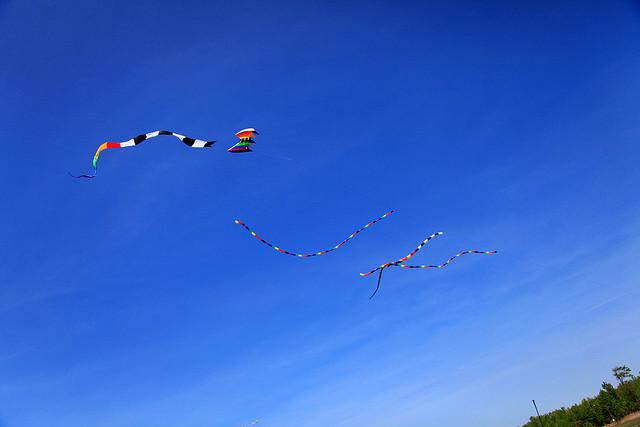Are there clouds visible?
Short answer required. No. What are the objects in the sky?
Give a very brief answer. Kites. Are there clouds in the sky?
Be succinct. No. What is in the sky?
Give a very brief answer. Kites. Is the sun shining brightly?
Answer briefly. Yes. Where is the kite with the black and white striped tail?
Answer briefly. In sky. 